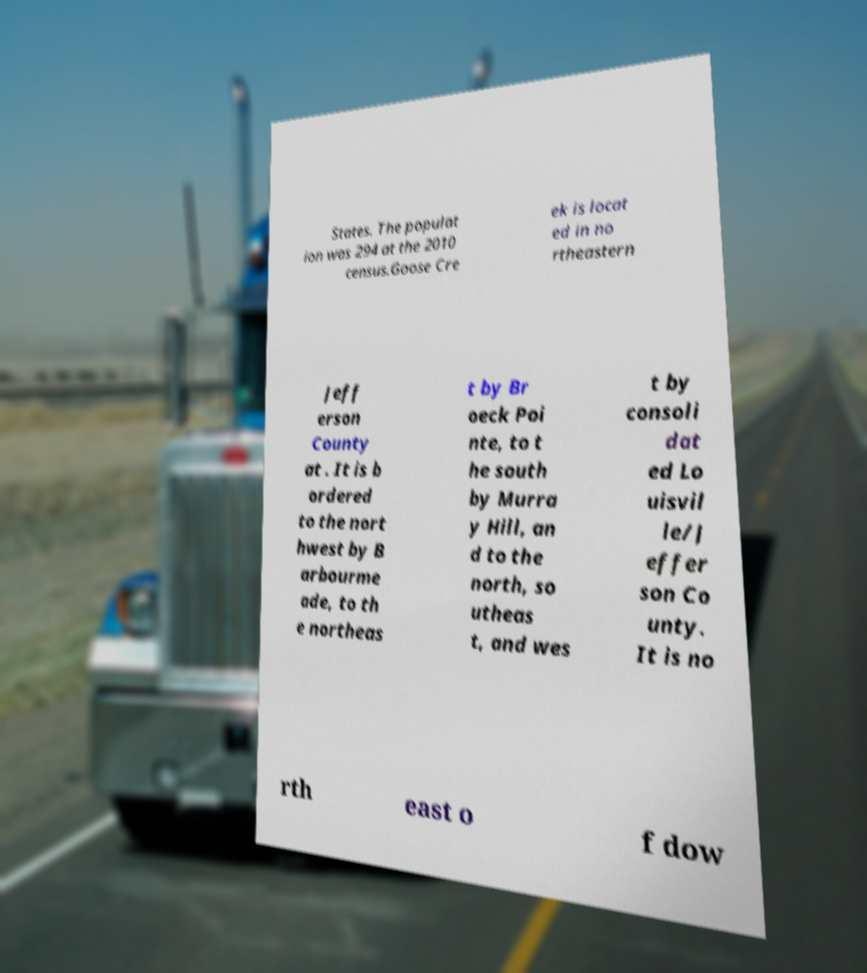I need the written content from this picture converted into text. Can you do that? States. The populat ion was 294 at the 2010 census.Goose Cre ek is locat ed in no rtheastern Jeff erson County at . It is b ordered to the nort hwest by B arbourme ade, to th e northeas t by Br oeck Poi nte, to t he south by Murra y Hill, an d to the north, so utheas t, and wes t by consoli dat ed Lo uisvil le/J effer son Co unty. It is no rth east o f dow 